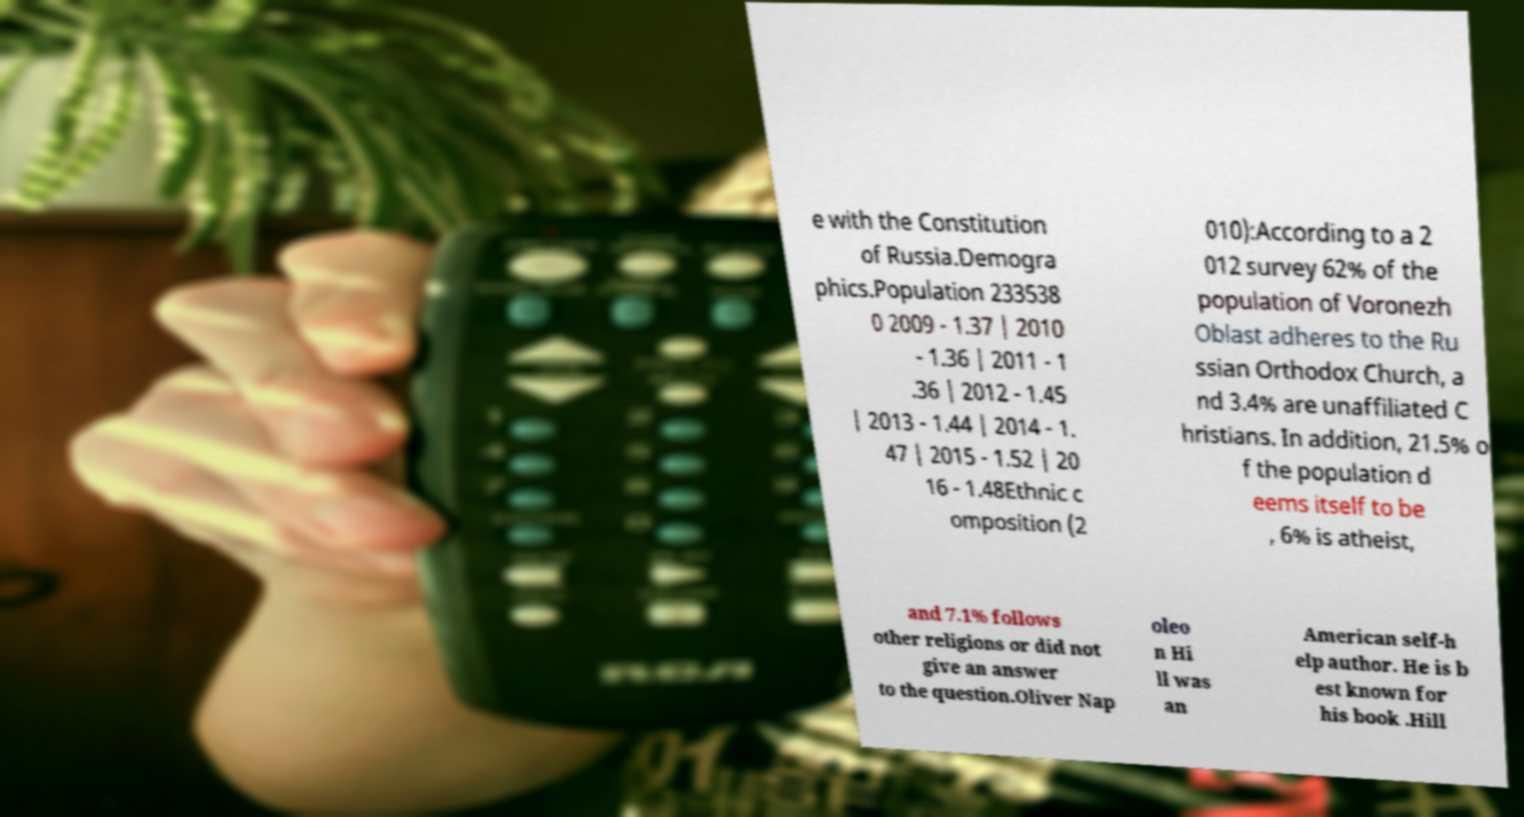Could you assist in decoding the text presented in this image and type it out clearly? e with the Constitution of Russia.Demogra phics.Population 233538 0 2009 - 1.37 | 2010 - 1.36 | 2011 - 1 .36 | 2012 - 1.45 | 2013 - 1.44 | 2014 - 1. 47 | 2015 - 1.52 | 20 16 - 1.48Ethnic c omposition (2 010):According to a 2 012 survey 62% of the population of Voronezh Oblast adheres to the Ru ssian Orthodox Church, a nd 3.4% are unaffiliated C hristians. In addition, 21.5% o f the population d eems itself to be , 6% is atheist, and 7.1% follows other religions or did not give an answer to the question.Oliver Nap oleo n Hi ll was an American self-h elp author. He is b est known for his book .Hill 